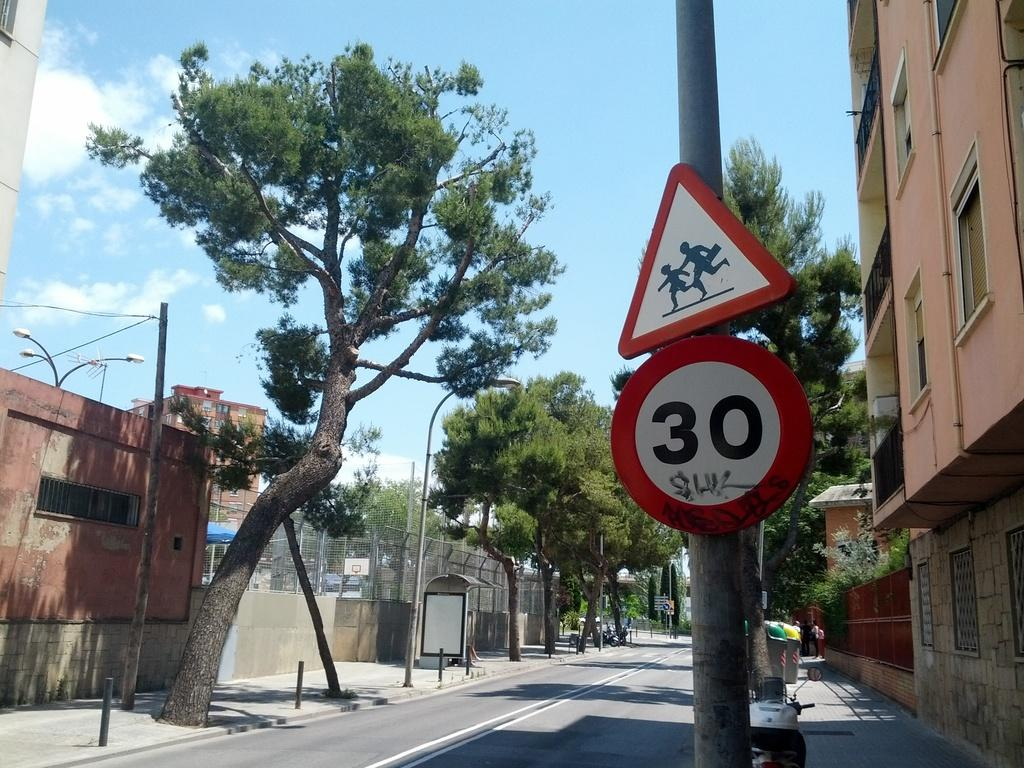<image>
Present a compact description of the photo's key features. Below a triangular pedestrian sign is a circular one with the number 30 on it. 